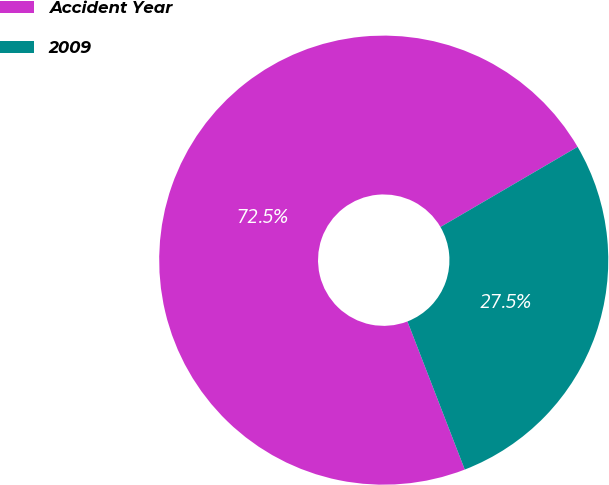<chart> <loc_0><loc_0><loc_500><loc_500><pie_chart><fcel>Accident Year<fcel>2009<nl><fcel>72.46%<fcel>27.54%<nl></chart> 